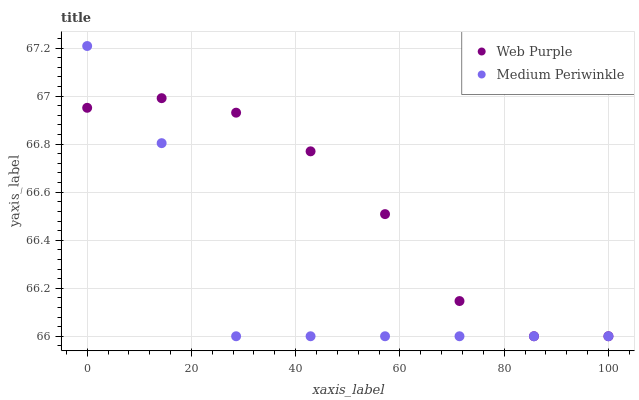Does Medium Periwinkle have the minimum area under the curve?
Answer yes or no. Yes. Does Web Purple have the maximum area under the curve?
Answer yes or no. Yes. Does Medium Periwinkle have the maximum area under the curve?
Answer yes or no. No. Is Web Purple the smoothest?
Answer yes or no. Yes. Is Medium Periwinkle the roughest?
Answer yes or no. Yes. Is Medium Periwinkle the smoothest?
Answer yes or no. No. Does Web Purple have the lowest value?
Answer yes or no. Yes. Does Medium Periwinkle have the highest value?
Answer yes or no. Yes. Does Medium Periwinkle intersect Web Purple?
Answer yes or no. Yes. Is Medium Periwinkle less than Web Purple?
Answer yes or no. No. Is Medium Periwinkle greater than Web Purple?
Answer yes or no. No. 